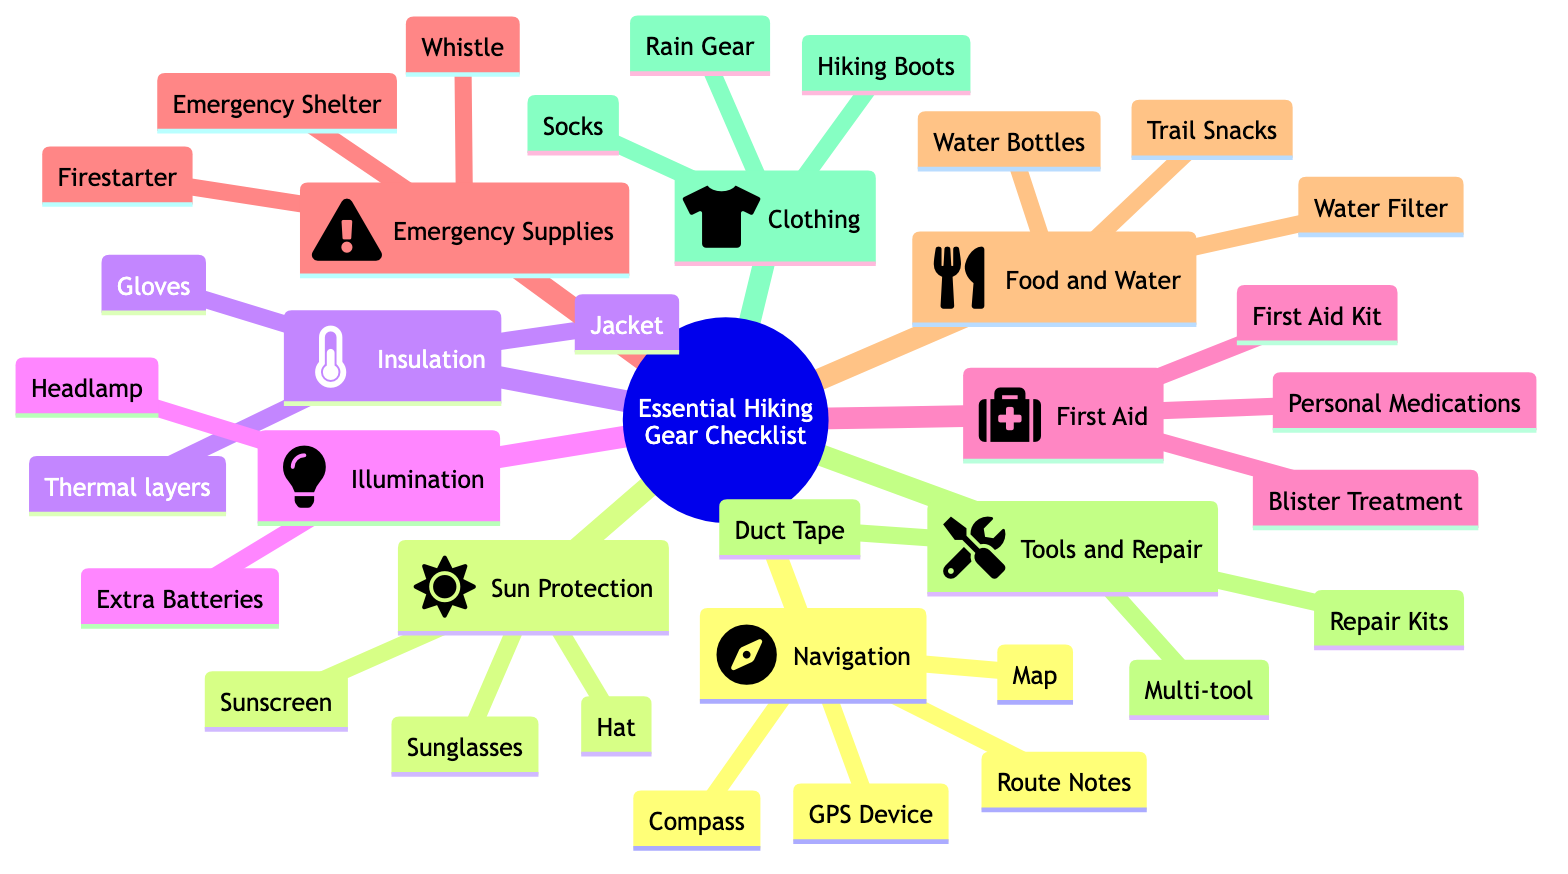What category includes a compass? The compass is listed under the "Navigation" category in the diagram. Each category contains specific gear essential for hiking, and "Navigation" specifically lists a compass among other items.
Answer: Navigation How many items are in the Food and Water category? The "Food and Water" category contains three items: water bottles, water filter, and trail snacks. This can be counted directly from the nodes under the category in the diagram.
Answer: 3 What is the primary purpose of the first aid kit? The first aid kit's primary purpose is to provide medical assistance, as indicated by its classification under the "First Aid" category, which focuses on health-related supplies for emergencies.
Answer: Medical assistance Which item is used for sun protection? Sunscreen is a specific item used for sun protection, as it is listed under the "Sun Protection" category alongside other protective gear like sunglasses and hats.
Answer: Sunscreen What is the total number of categories in this checklist? The diagram presents a total of nine distinct categories related to essential hiking gear, each with its own set of items. These can be counted on the top-level nodes of the diagram.
Answer: 9 Which category includes a firestarter? The firestarter is included in the "Emergency Supplies" category. This can be determined by looking for the item within the designated grouping aimed at emergency preparedness.
Answer: Emergency Supplies What dual function does the multi-tool serve? The multi-tool serves the dual functions of both tool and repair, as it is designed for various tasks and is categorized under "Tools and Repair" which implies its usability in fixing or managing equipment on a hike.
Answer: Tool and repair What is the brand of the headlamp listed? The brand of the headlamp listed is Petzl, specified in the "Illumination" category, which contains items to provide light during nighttime or low-visibility hiking situations.
Answer: Petzl How many items are classified under Insulation? There are three items classified under the "Insulation" category: jacket, thermal layers, and gloves. This number can be easily counted from the listed items underneath the Insulation node in the diagram.
Answer: 3 